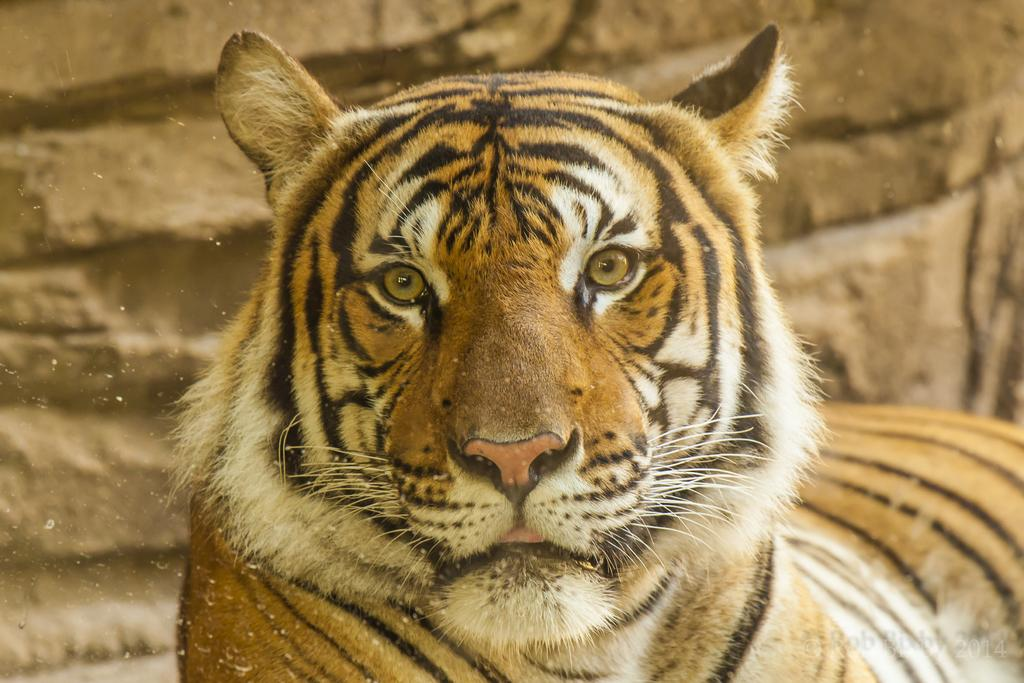What animal is the main subject of the image? There is a cheetah in the middle of the image. What can be seen in the background of the image? There are rocks visible in the background of the image. What type of quill is the cheetah using to write a letter in the image? There is no quill or letter-writing activity present in the image; the cheetah is simply standing in the middle of the image. 